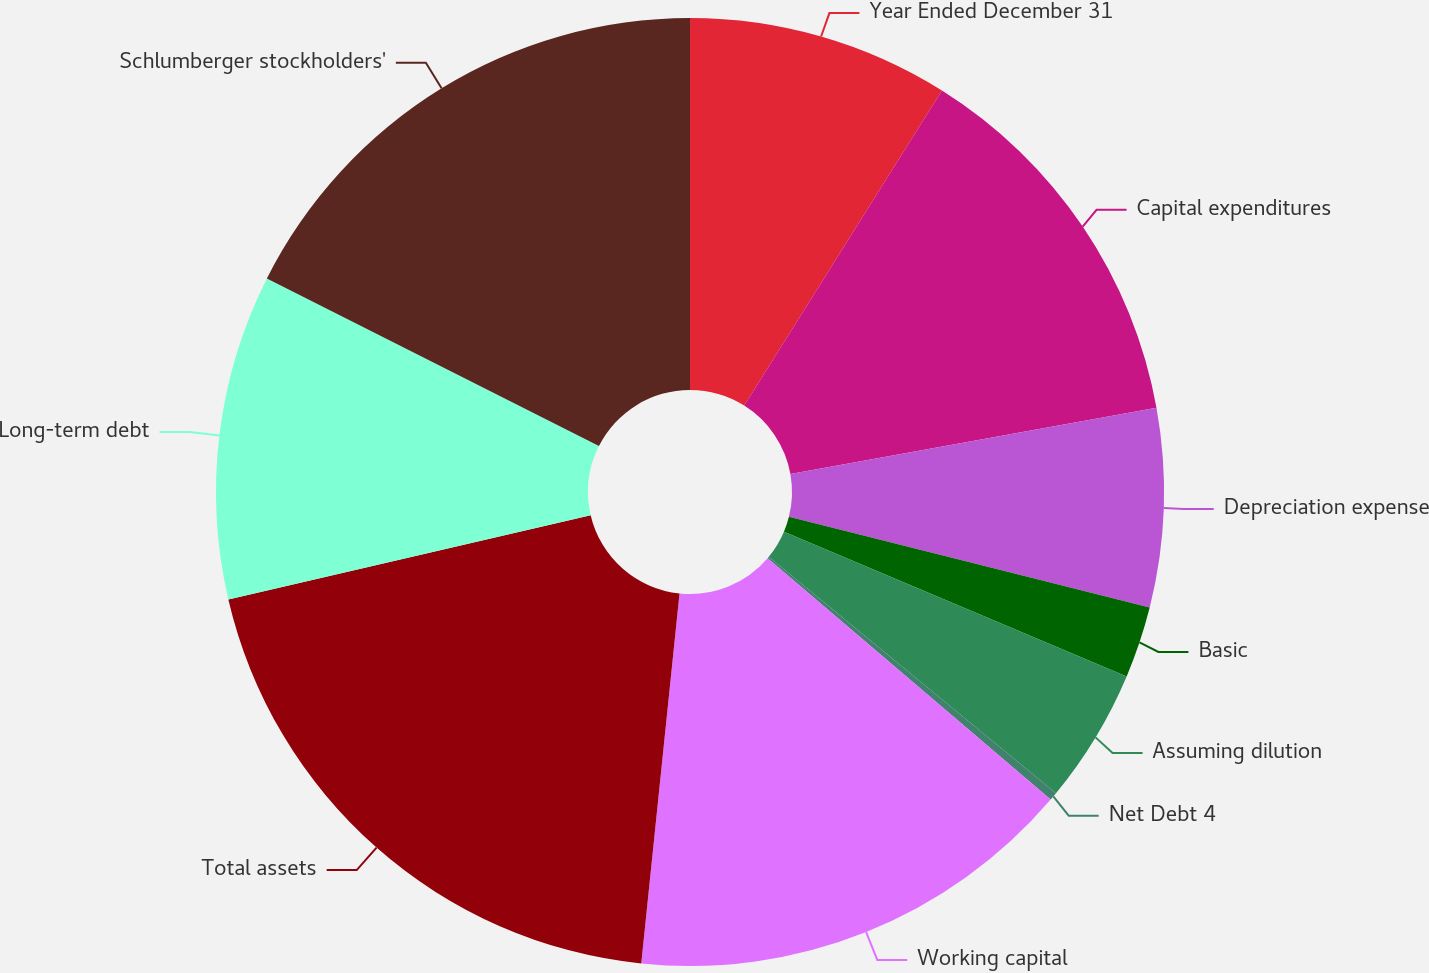Convert chart. <chart><loc_0><loc_0><loc_500><loc_500><pie_chart><fcel>Year Ended December 31<fcel>Capital expenditures<fcel>Depreciation expense<fcel>Basic<fcel>Assuming dilution<fcel>Net Debt 4<fcel>Working capital<fcel>Total assets<fcel>Long-term debt<fcel>Schlumberger stockholders'<nl><fcel>8.92%<fcel>13.24%<fcel>6.76%<fcel>2.44%<fcel>4.6%<fcel>0.28%<fcel>15.4%<fcel>19.72%<fcel>11.08%<fcel>17.56%<nl></chart> 